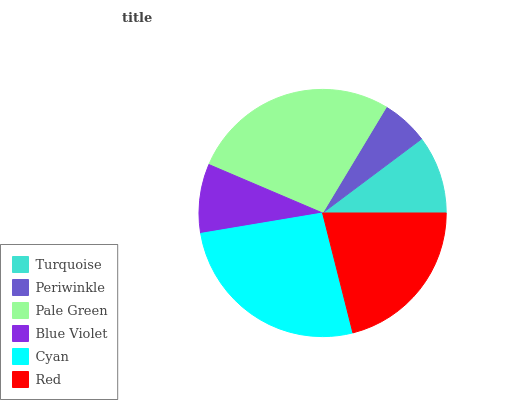Is Periwinkle the minimum?
Answer yes or no. Yes. Is Pale Green the maximum?
Answer yes or no. Yes. Is Pale Green the minimum?
Answer yes or no. No. Is Periwinkle the maximum?
Answer yes or no. No. Is Pale Green greater than Periwinkle?
Answer yes or no. Yes. Is Periwinkle less than Pale Green?
Answer yes or no. Yes. Is Periwinkle greater than Pale Green?
Answer yes or no. No. Is Pale Green less than Periwinkle?
Answer yes or no. No. Is Red the high median?
Answer yes or no. Yes. Is Turquoise the low median?
Answer yes or no. Yes. Is Periwinkle the high median?
Answer yes or no. No. Is Red the low median?
Answer yes or no. No. 